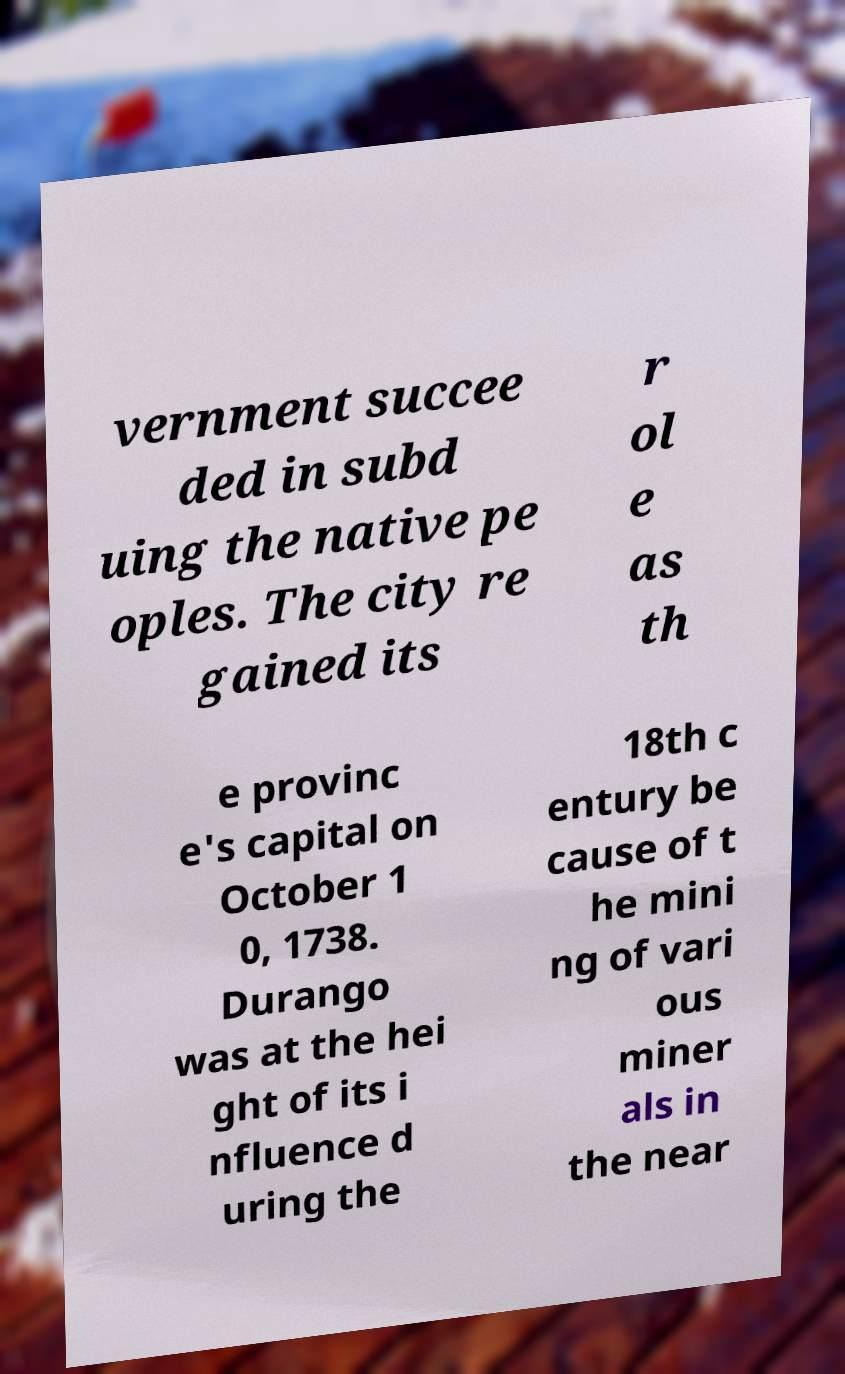Could you assist in decoding the text presented in this image and type it out clearly? vernment succee ded in subd uing the native pe oples. The city re gained its r ol e as th e provinc e's capital on October 1 0, 1738. Durango was at the hei ght of its i nfluence d uring the 18th c entury be cause of t he mini ng of vari ous miner als in the near 